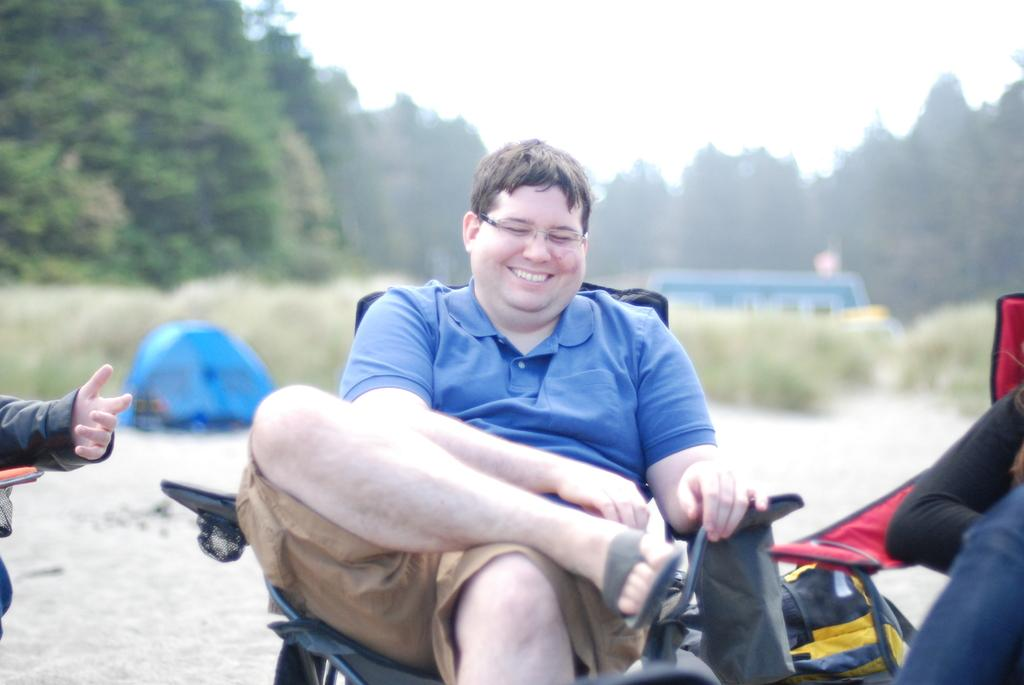What is the person in the image doing? There is a person sitting on a chair in the image. Are there any other people in the image? Yes, there are other people near the person sitting on the chair. What can be seen in the background of the image? There are trees and plants visible in the image. What type of jeans is the person wearing in the image? There is no mention of jeans in the image, so it cannot be determined what type the person might be wearing. 